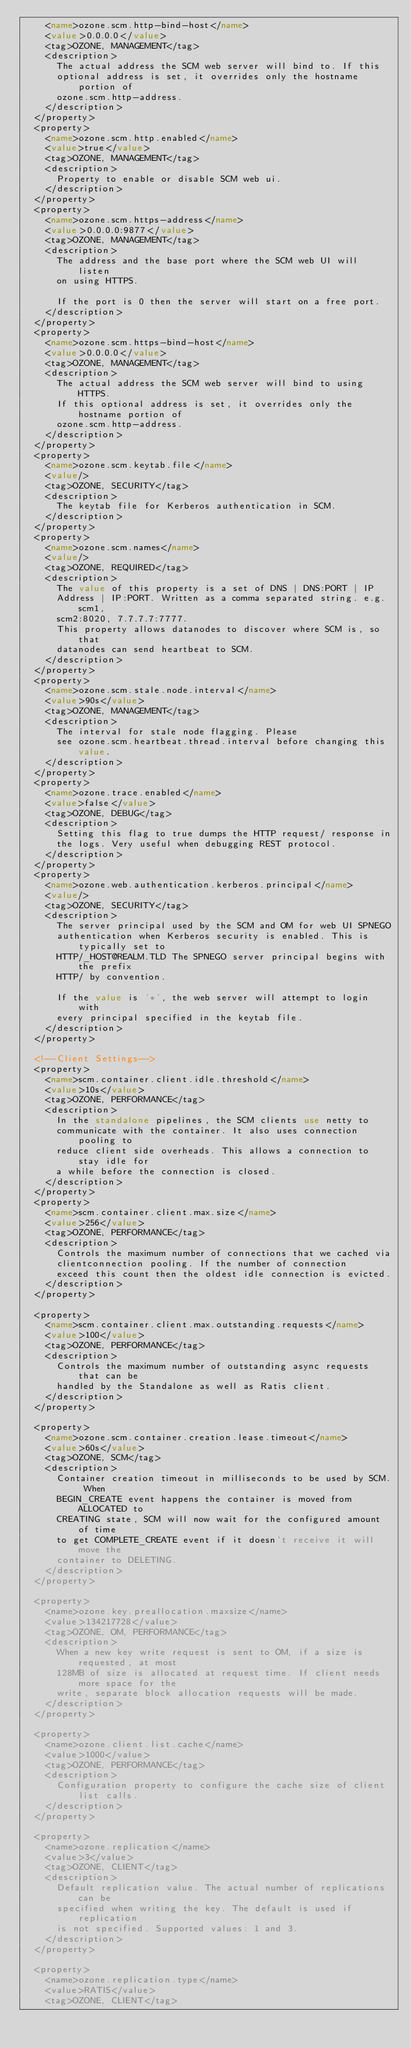Convert code to text. <code><loc_0><loc_0><loc_500><loc_500><_XML_>    <name>ozone.scm.http-bind-host</name>
    <value>0.0.0.0</value>
    <tag>OZONE, MANAGEMENT</tag>
    <description>
      The actual address the SCM web server will bind to. If this
      optional address is set, it overrides only the hostname portion of
      ozone.scm.http-address.
    </description>
  </property>
  <property>
    <name>ozone.scm.http.enabled</name>
    <value>true</value>
    <tag>OZONE, MANAGEMENT</tag>
    <description>
      Property to enable or disable SCM web ui.
    </description>
  </property>
  <property>
    <name>ozone.scm.https-address</name>
    <value>0.0.0.0:9877</value>
    <tag>OZONE, MANAGEMENT</tag>
    <description>
      The address and the base port where the SCM web UI will listen
      on using HTTPS.

      If the port is 0 then the server will start on a free port.
    </description>
  </property>
  <property>
    <name>ozone.scm.https-bind-host</name>
    <value>0.0.0.0</value>
    <tag>OZONE, MANAGEMENT</tag>
    <description>
      The actual address the SCM web server will bind to using HTTPS.
      If this optional address is set, it overrides only the hostname portion of
      ozone.scm.http-address.
    </description>
  </property>
  <property>
    <name>ozone.scm.keytab.file</name>
    <value/>
    <tag>OZONE, SECURITY</tag>
    <description>
      The keytab file for Kerberos authentication in SCM.
    </description>
  </property>
  <property>
    <name>ozone.scm.names</name>
    <value/>
    <tag>OZONE, REQUIRED</tag>
    <description>
      The value of this property is a set of DNS | DNS:PORT | IP
      Address | IP:PORT. Written as a comma separated string. e.g. scm1,
      scm2:8020, 7.7.7.7:7777.
      This property allows datanodes to discover where SCM is, so that
      datanodes can send heartbeat to SCM.
    </description>
  </property>
  <property>
    <name>ozone.scm.stale.node.interval</name>
    <value>90s</value>
    <tag>OZONE, MANAGEMENT</tag>
    <description>
      The interval for stale node flagging. Please
      see ozone.scm.heartbeat.thread.interval before changing this value.
    </description>
  </property>
  <property>
    <name>ozone.trace.enabled</name>
    <value>false</value>
    <tag>OZONE, DEBUG</tag>
    <description>
      Setting this flag to true dumps the HTTP request/ response in
      the logs. Very useful when debugging REST protocol.
    </description>
  </property>
  <property>
    <name>ozone.web.authentication.kerberos.principal</name>
    <value/>
    <tag>OZONE, SECURITY</tag>
    <description>
      The server principal used by the SCM and OM for web UI SPNEGO
      authentication when Kerberos security is enabled. This is typically set to
      HTTP/_HOST@REALM.TLD The SPNEGO server principal begins with the prefix
      HTTP/ by convention.

      If the value is '*', the web server will attempt to login with
      every principal specified in the keytab file.
    </description>
  </property>

  <!--Client Settings-->
  <property>
    <name>scm.container.client.idle.threshold</name>
    <value>10s</value>
    <tag>OZONE, PERFORMANCE</tag>
    <description>
      In the standalone pipelines, the SCM clients use netty to
      communicate with the container. It also uses connection pooling to
      reduce client side overheads. This allows a connection to stay idle for
      a while before the connection is closed.
    </description>
  </property>
  <property>
    <name>scm.container.client.max.size</name>
    <value>256</value>
    <tag>OZONE, PERFORMANCE</tag>
    <description>
      Controls the maximum number of connections that we cached via
      clientconnection pooling. If the number of connection
      exceed this count then the oldest idle connection is evicted.
    </description>
  </property>

  <property>
    <name>scm.container.client.max.outstanding.requests</name>
    <value>100</value>
    <tag>OZONE, PERFORMANCE</tag>
    <description>
      Controls the maximum number of outstanding async requests that can be
      handled by the Standalone as well as Ratis client.
    </description>
  </property>

  <property>
    <name>ozone.scm.container.creation.lease.timeout</name>
    <value>60s</value>
    <tag>OZONE, SCM</tag>
    <description>
      Container creation timeout in milliseconds to be used by SCM. When
      BEGIN_CREATE event happens the container is moved from ALLOCATED to
      CREATING state, SCM will now wait for the configured amount of time
      to get COMPLETE_CREATE event if it doesn't receive it will move the
      container to DELETING.
    </description>
  </property>

  <property>
    <name>ozone.key.preallocation.maxsize</name>
    <value>134217728</value>
    <tag>OZONE, OM, PERFORMANCE</tag>
    <description>
      When a new key write request is sent to OM, if a size is requested, at most
      128MB of size is allocated at request time. If client needs more space for the
      write, separate block allocation requests will be made.
    </description>
  </property>

  <property>
    <name>ozone.client.list.cache</name>
    <value>1000</value>
    <tag>OZONE, PERFORMANCE</tag>
    <description>
      Configuration property to configure the cache size of client list calls.
    </description>
  </property>

  <property>
    <name>ozone.replication</name>
    <value>3</value>
    <tag>OZONE, CLIENT</tag>
    <description>
      Default replication value. The actual number of replications can be
      specified when writing the key. The default is used if replication
      is not specified. Supported values: 1 and 3.
    </description>
  </property>

  <property>
    <name>ozone.replication.type</name>
    <value>RATIS</value>
    <tag>OZONE, CLIENT</tag></code> 